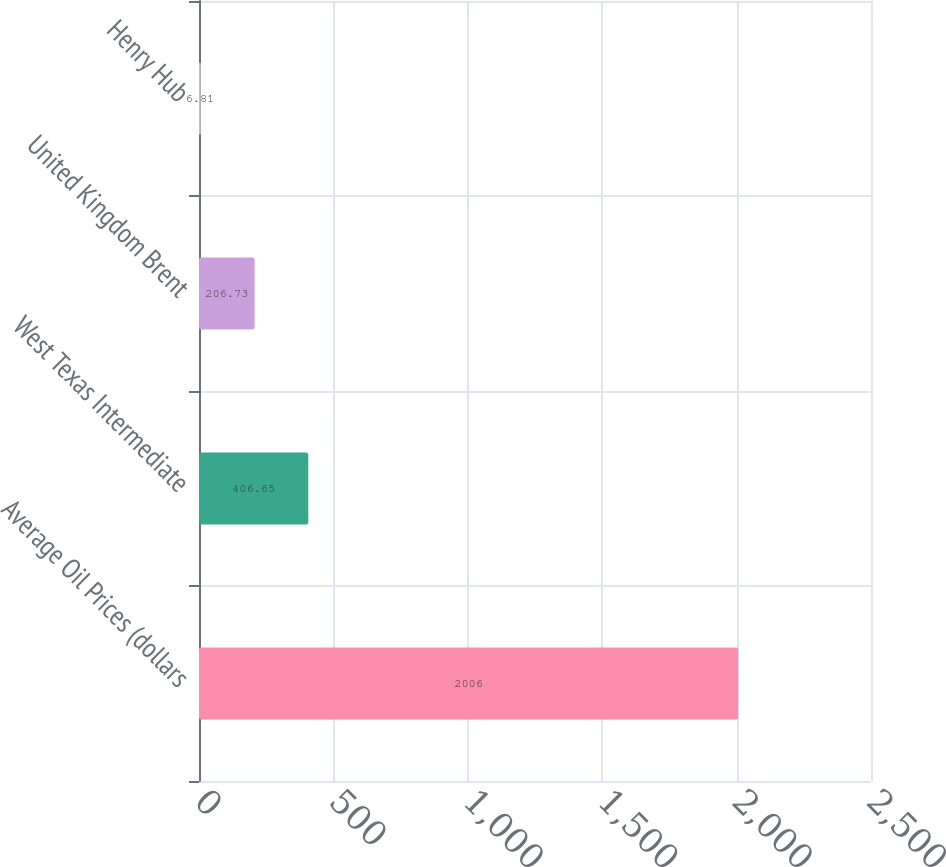<chart> <loc_0><loc_0><loc_500><loc_500><bar_chart><fcel>Average Oil Prices (dollars<fcel>West Texas Intermediate<fcel>United Kingdom Brent<fcel>Henry Hub<nl><fcel>2006<fcel>406.65<fcel>206.73<fcel>6.81<nl></chart> 